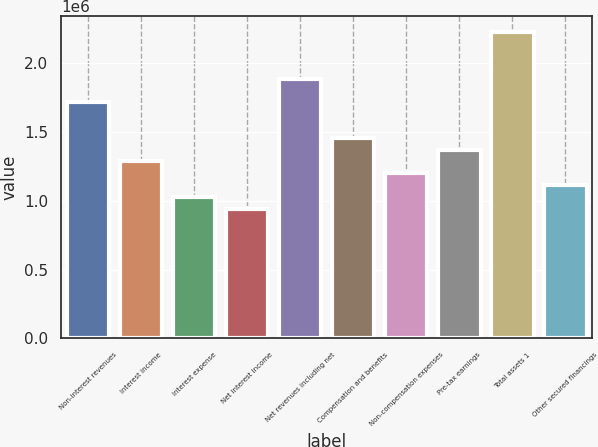<chart> <loc_0><loc_0><loc_500><loc_500><bar_chart><fcel>Non-interest revenues<fcel>Interest income<fcel>Interest expense<fcel>Net interest income<fcel>Net revenues including net<fcel>Compensation and benefits<fcel>Non-compensation expenses<fcel>Pre-tax earnings<fcel>Total assets 1<fcel>Other secured financings<nl><fcel>1.71168e+06<fcel>1.28376e+06<fcel>1.02701e+06<fcel>941426<fcel>1.88285e+06<fcel>1.45493e+06<fcel>1.19818e+06<fcel>1.36935e+06<fcel>2.22519e+06<fcel>1.11259e+06<nl></chart> 